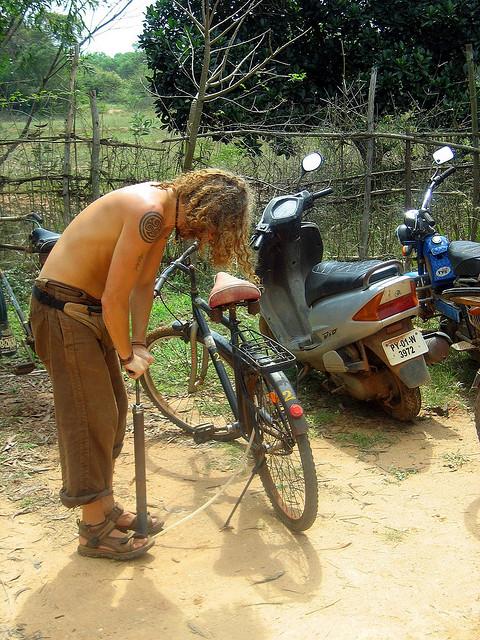How much air does the tire hold?
Keep it brief. Not much. Why is he shirtless?
Give a very brief answer. It's hot. Does he have a tattoo?
Answer briefly. Yes. 